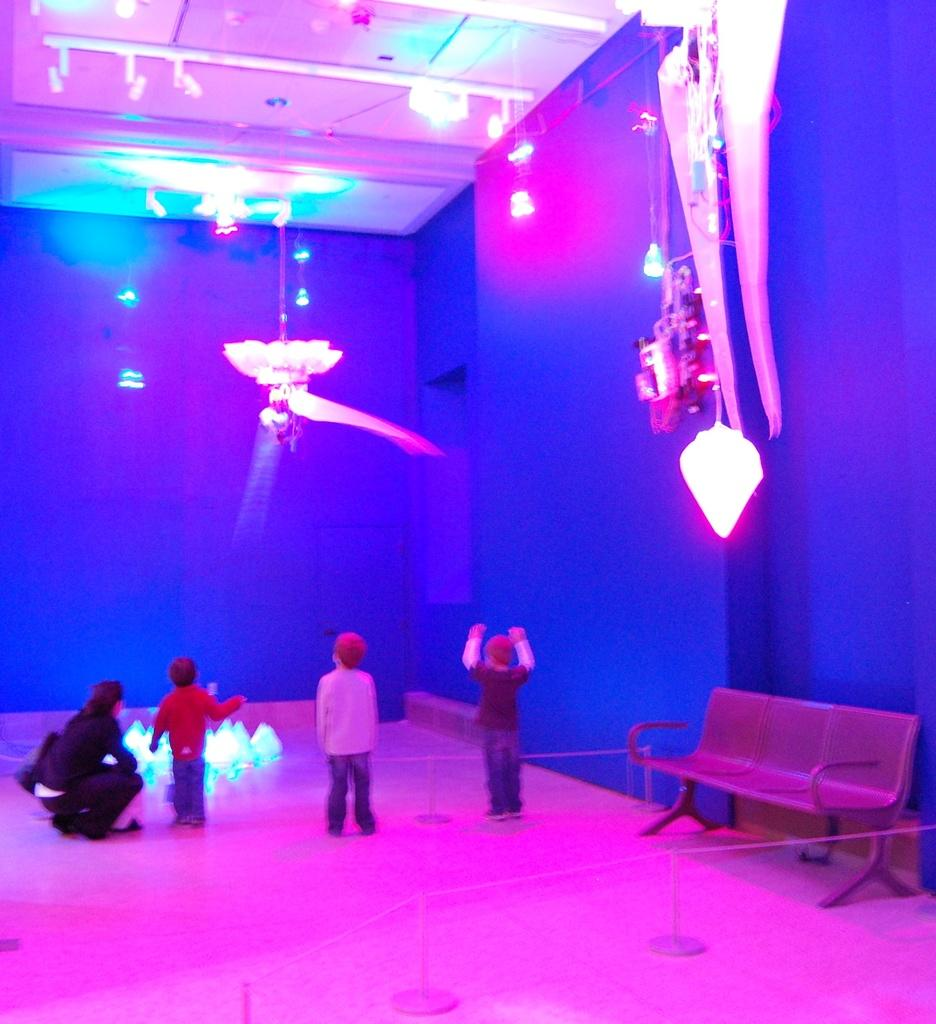How many kids are in the image? There are three kids in the image. Who else is present in the image besides the kids? There is a woman in the image. What is the woman doing in the image? The woman is sitting on the floor. What type of furniture can be seen in the image? There is a bench in the image. What is visible at the top of the image? There are lights visible at the top of the image. What type of mint is growing on the bench in the image? There is no mint present in the image, and the bench does not have any plants growing on it. Can you tell me how many partners the woman has in the image? There is no indication of a partner or relationship in the image, as it only shows the woman sitting on the floor with three kids. 